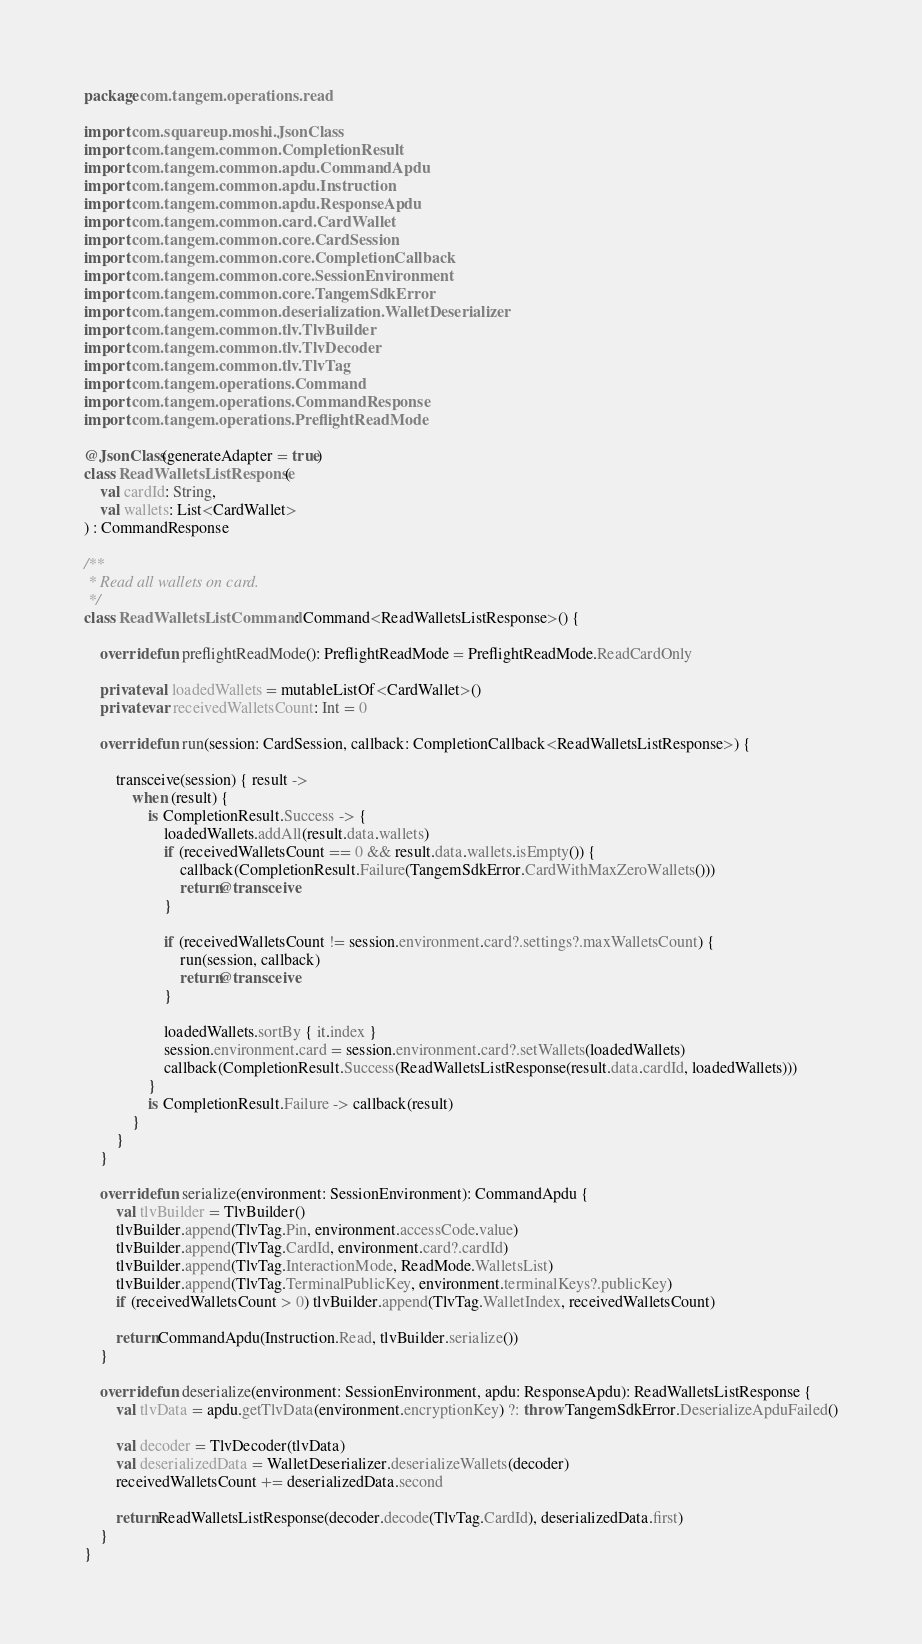<code> <loc_0><loc_0><loc_500><loc_500><_Kotlin_>package com.tangem.operations.read

import com.squareup.moshi.JsonClass
import com.tangem.common.CompletionResult
import com.tangem.common.apdu.CommandApdu
import com.tangem.common.apdu.Instruction
import com.tangem.common.apdu.ResponseApdu
import com.tangem.common.card.CardWallet
import com.tangem.common.core.CardSession
import com.tangem.common.core.CompletionCallback
import com.tangem.common.core.SessionEnvironment
import com.tangem.common.core.TangemSdkError
import com.tangem.common.deserialization.WalletDeserializer
import com.tangem.common.tlv.TlvBuilder
import com.tangem.common.tlv.TlvDecoder
import com.tangem.common.tlv.TlvTag
import com.tangem.operations.Command
import com.tangem.operations.CommandResponse
import com.tangem.operations.PreflightReadMode

@JsonClass(generateAdapter = true)
class ReadWalletsListResponse(
    val cardId: String,
    val wallets: List<CardWallet>
) : CommandResponse

/**
 * Read all wallets on card.
 */
class ReadWalletsListCommand : Command<ReadWalletsListResponse>() {

    override fun preflightReadMode(): PreflightReadMode = PreflightReadMode.ReadCardOnly

    private val loadedWallets = mutableListOf<CardWallet>()
    private var receivedWalletsCount: Int = 0

    override fun run(session: CardSession, callback: CompletionCallback<ReadWalletsListResponse>) {

        transceive(session) { result ->
            when (result) {
                is CompletionResult.Success -> {
                    loadedWallets.addAll(result.data.wallets)
                    if (receivedWalletsCount == 0 && result.data.wallets.isEmpty()) {
                        callback(CompletionResult.Failure(TangemSdkError.CardWithMaxZeroWallets()))
                        return@transceive
                    }

                    if (receivedWalletsCount != session.environment.card?.settings?.maxWalletsCount) {
                        run(session, callback)
                        return@transceive
                    }

                    loadedWallets.sortBy { it.index }
                    session.environment.card = session.environment.card?.setWallets(loadedWallets)
                    callback(CompletionResult.Success(ReadWalletsListResponse(result.data.cardId, loadedWallets)))
                }
                is CompletionResult.Failure -> callback(result)
            }
        }
    }

    override fun serialize(environment: SessionEnvironment): CommandApdu {
        val tlvBuilder = TlvBuilder()
        tlvBuilder.append(TlvTag.Pin, environment.accessCode.value)
        tlvBuilder.append(TlvTag.CardId, environment.card?.cardId)
        tlvBuilder.append(TlvTag.InteractionMode, ReadMode.WalletsList)
        tlvBuilder.append(TlvTag.TerminalPublicKey, environment.terminalKeys?.publicKey)
        if (receivedWalletsCount > 0) tlvBuilder.append(TlvTag.WalletIndex, receivedWalletsCount)

        return CommandApdu(Instruction.Read, tlvBuilder.serialize())
    }

    override fun deserialize(environment: SessionEnvironment, apdu: ResponseApdu): ReadWalletsListResponse {
        val tlvData = apdu.getTlvData(environment.encryptionKey) ?: throw TangemSdkError.DeserializeApduFailed()

        val decoder = TlvDecoder(tlvData)
        val deserializedData = WalletDeserializer.deserializeWallets(decoder)
        receivedWalletsCount += deserializedData.second

        return ReadWalletsListResponse(decoder.decode(TlvTag.CardId), deserializedData.first)
    }
}</code> 